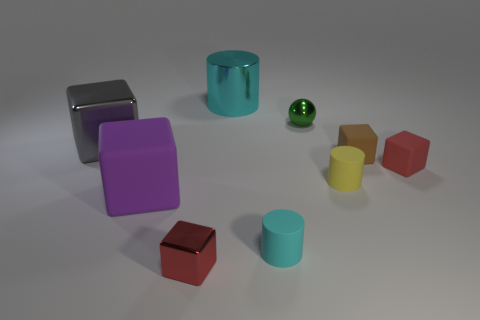Subtract all large metallic blocks. How many blocks are left? 4 Subtract all red spheres. Subtract all cyan cubes. How many spheres are left? 1 Add 1 yellow shiny balls. How many objects exist? 10 Subtract all cylinders. How many objects are left? 6 Add 9 big cyan cylinders. How many big cyan cylinders exist? 10 Subtract 0 cyan balls. How many objects are left? 9 Subtract all tiny yellow blocks. Subtract all brown things. How many objects are left? 8 Add 5 large rubber blocks. How many large rubber blocks are left? 6 